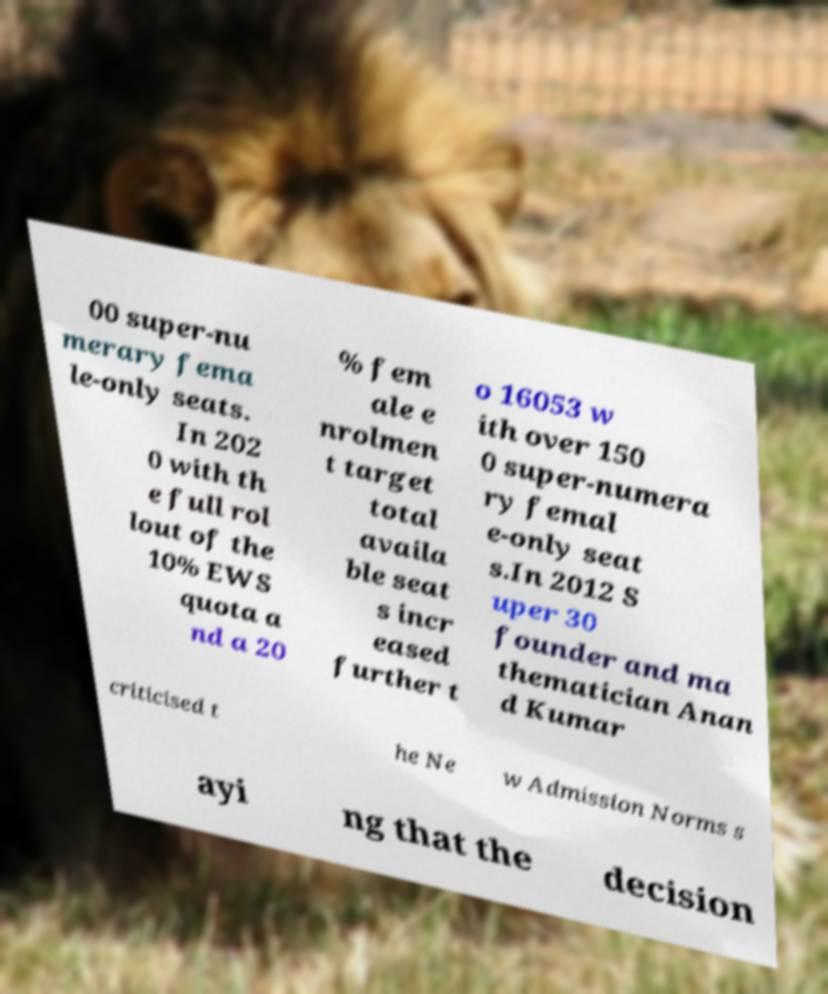Could you assist in decoding the text presented in this image and type it out clearly? 00 super-nu merary fema le-only seats. In 202 0 with th e full rol lout of the 10% EWS quota a nd a 20 % fem ale e nrolmen t target total availa ble seat s incr eased further t o 16053 w ith over 150 0 super-numera ry femal e-only seat s.In 2012 S uper 30 founder and ma thematician Anan d Kumar criticised t he Ne w Admission Norms s ayi ng that the decision 